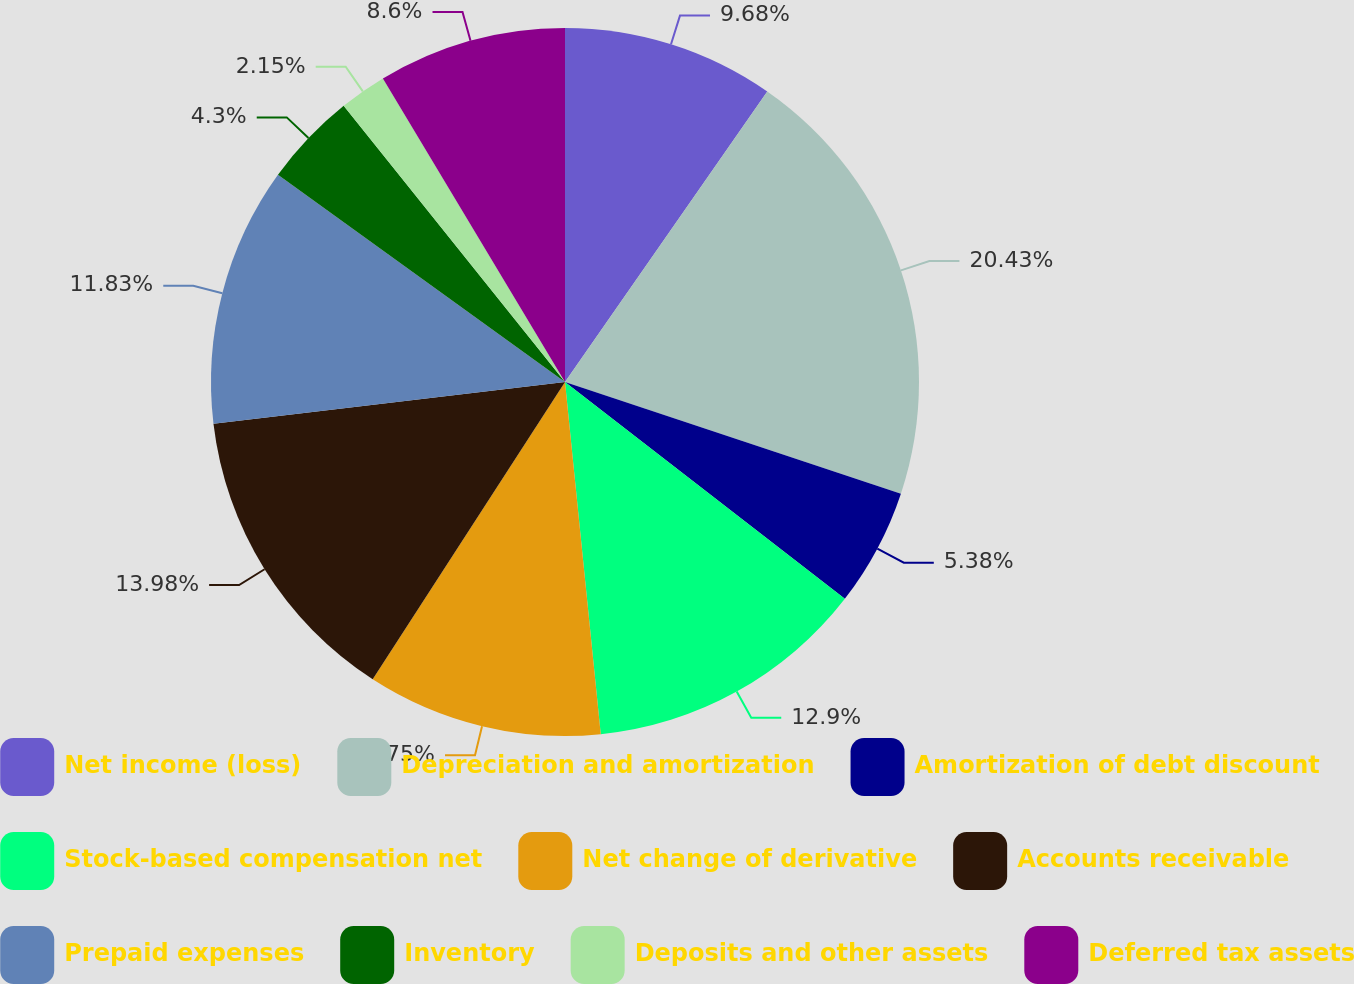Convert chart to OTSL. <chart><loc_0><loc_0><loc_500><loc_500><pie_chart><fcel>Net income (loss)<fcel>Depreciation and amortization<fcel>Amortization of debt discount<fcel>Stock-based compensation net<fcel>Net change of derivative<fcel>Accounts receivable<fcel>Prepaid expenses<fcel>Inventory<fcel>Deposits and other assets<fcel>Deferred tax assets<nl><fcel>9.68%<fcel>20.43%<fcel>5.38%<fcel>12.9%<fcel>10.75%<fcel>13.98%<fcel>11.83%<fcel>4.3%<fcel>2.15%<fcel>8.6%<nl></chart> 